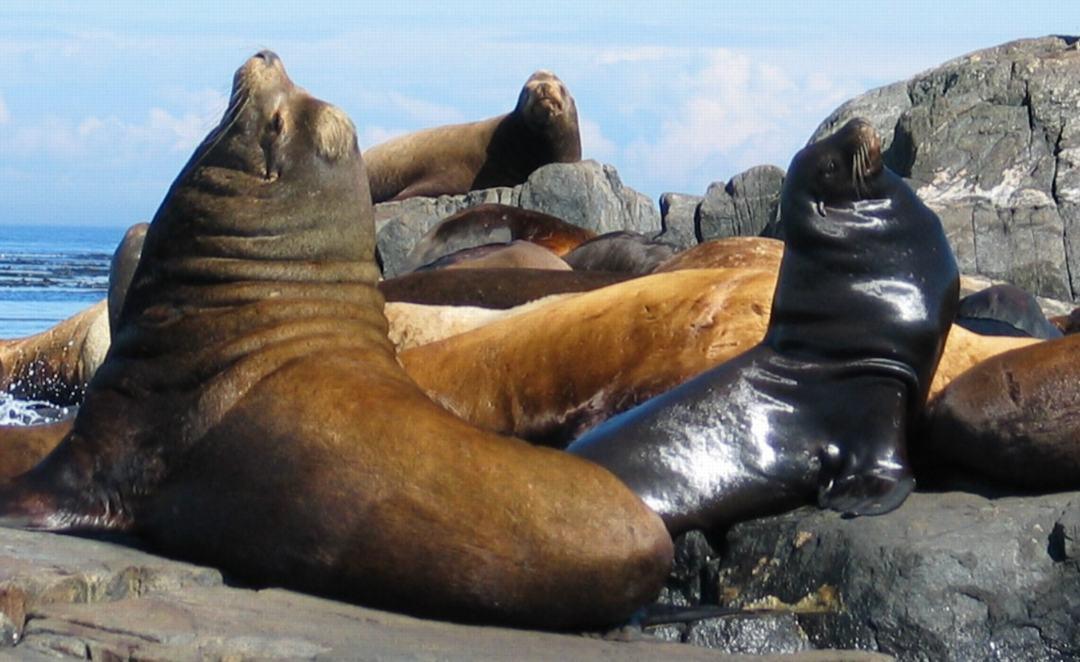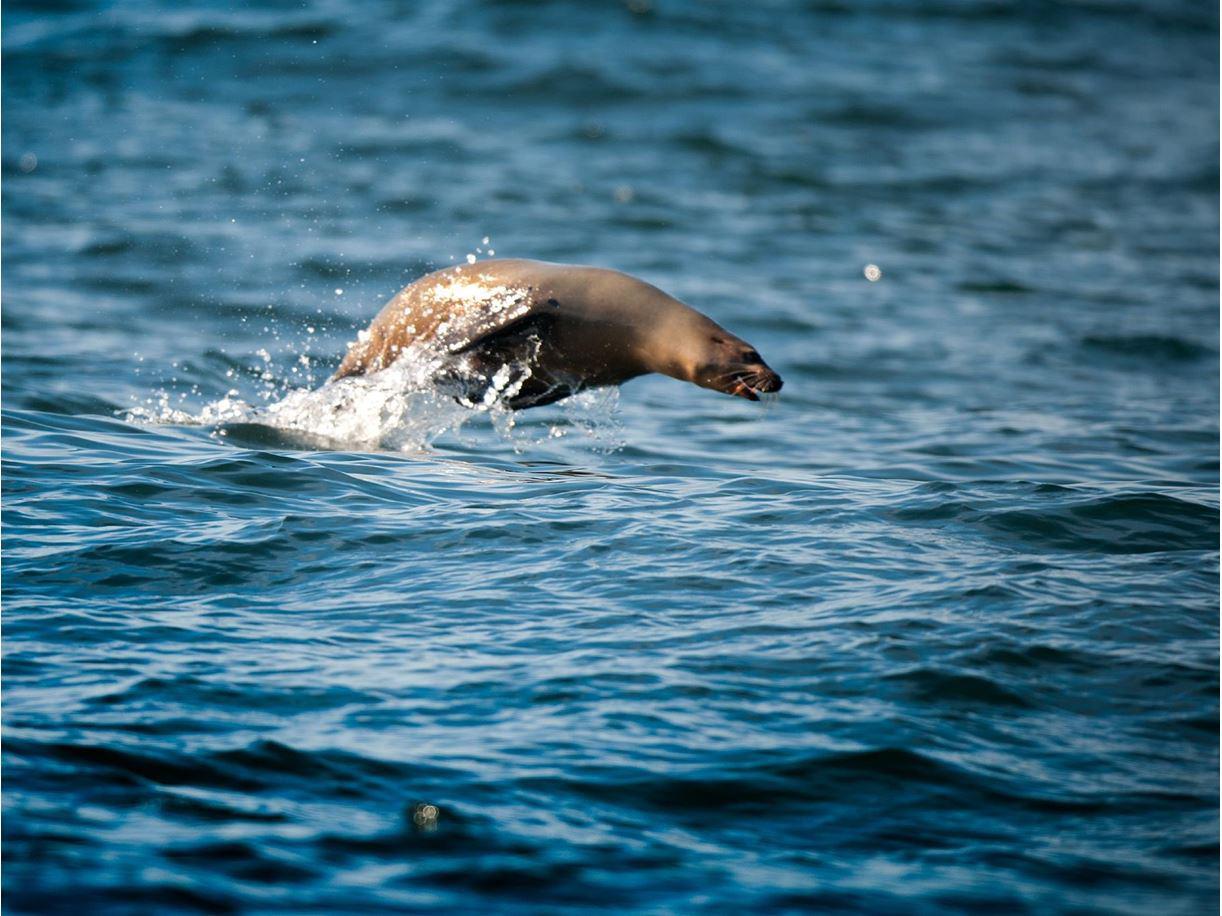The first image is the image on the left, the second image is the image on the right. For the images displayed, is the sentence "There is exactly one seal sitting on a rock in the image on the right." factually correct? Answer yes or no. No. 